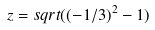Convert formula to latex. <formula><loc_0><loc_0><loc_500><loc_500>z = s q r t ( ( - 1 / 3 ) ^ { 2 } - 1 )</formula> 